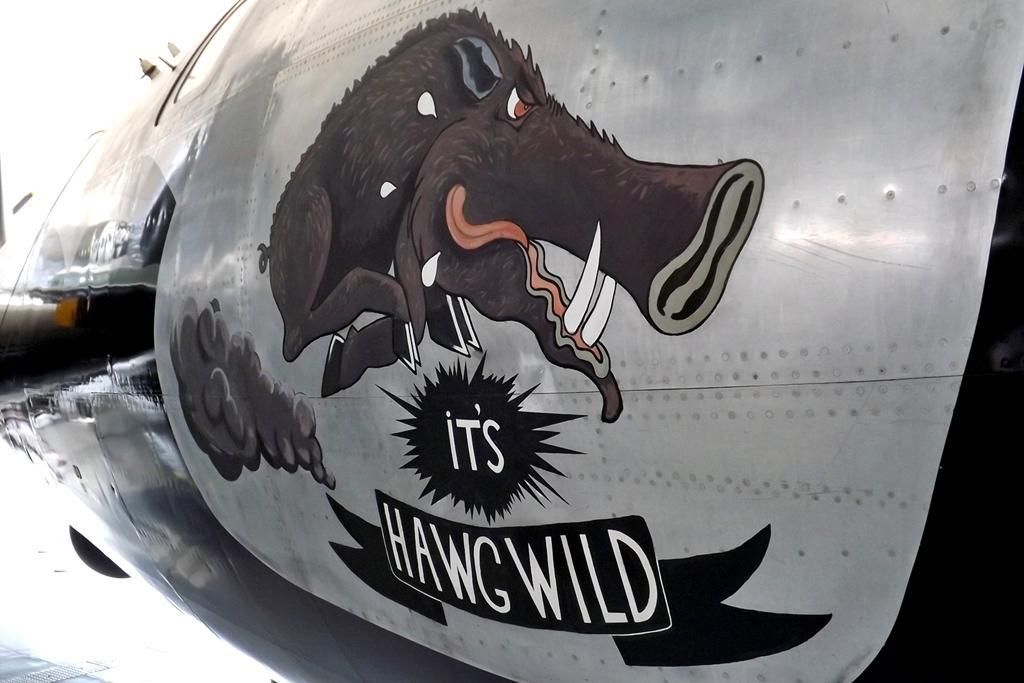Please provide a concise description of this image. In this image may be there is a aircraft part, on which there is a text, animal image. 